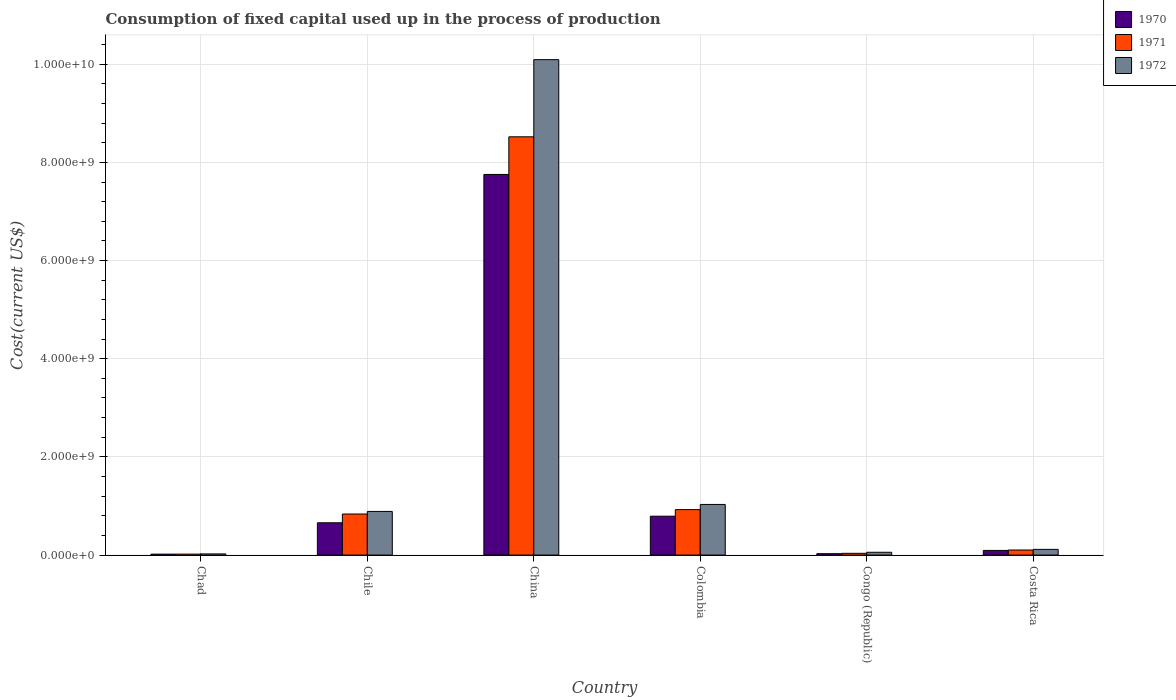How many different coloured bars are there?
Make the answer very short. 3. How many groups of bars are there?
Offer a very short reply. 6. How many bars are there on the 4th tick from the left?
Your answer should be very brief. 3. What is the label of the 1st group of bars from the left?
Offer a very short reply. Chad. In how many cases, is the number of bars for a given country not equal to the number of legend labels?
Keep it short and to the point. 0. What is the amount consumed in the process of production in 1970 in Chile?
Make the answer very short. 6.58e+08. Across all countries, what is the maximum amount consumed in the process of production in 1970?
Provide a succinct answer. 7.75e+09. Across all countries, what is the minimum amount consumed in the process of production in 1972?
Ensure brevity in your answer.  2.37e+07. In which country was the amount consumed in the process of production in 1970 minimum?
Make the answer very short. Chad. What is the total amount consumed in the process of production in 1971 in the graph?
Keep it short and to the point. 1.04e+1. What is the difference between the amount consumed in the process of production in 1971 in Chile and that in Costa Rica?
Offer a very short reply. 7.34e+08. What is the difference between the amount consumed in the process of production in 1971 in Costa Rica and the amount consumed in the process of production in 1972 in China?
Ensure brevity in your answer.  -9.99e+09. What is the average amount consumed in the process of production in 1970 per country?
Your response must be concise. 1.56e+09. What is the difference between the amount consumed in the process of production of/in 1971 and amount consumed in the process of production of/in 1972 in Chad?
Offer a very short reply. -4.50e+06. What is the ratio of the amount consumed in the process of production in 1972 in Chile to that in Colombia?
Provide a short and direct response. 0.86. Is the amount consumed in the process of production in 1971 in Chad less than that in China?
Make the answer very short. Yes. What is the difference between the highest and the second highest amount consumed in the process of production in 1970?
Keep it short and to the point. 6.96e+09. What is the difference between the highest and the lowest amount consumed in the process of production in 1970?
Keep it short and to the point. 7.74e+09. Is the sum of the amount consumed in the process of production in 1972 in China and Costa Rica greater than the maximum amount consumed in the process of production in 1971 across all countries?
Keep it short and to the point. Yes. What does the 3rd bar from the left in China represents?
Your response must be concise. 1972. Is it the case that in every country, the sum of the amount consumed in the process of production in 1970 and amount consumed in the process of production in 1972 is greater than the amount consumed in the process of production in 1971?
Provide a short and direct response. Yes. How many bars are there?
Offer a terse response. 18. Are the values on the major ticks of Y-axis written in scientific E-notation?
Ensure brevity in your answer.  Yes. Does the graph contain grids?
Offer a very short reply. Yes. What is the title of the graph?
Make the answer very short. Consumption of fixed capital used up in the process of production. What is the label or title of the Y-axis?
Keep it short and to the point. Cost(current US$). What is the Cost(current US$) of 1970 in Chad?
Give a very brief answer. 1.87e+07. What is the Cost(current US$) of 1971 in Chad?
Provide a succinct answer. 1.92e+07. What is the Cost(current US$) in 1972 in Chad?
Ensure brevity in your answer.  2.37e+07. What is the Cost(current US$) of 1970 in Chile?
Give a very brief answer. 6.58e+08. What is the Cost(current US$) of 1971 in Chile?
Provide a short and direct response. 8.37e+08. What is the Cost(current US$) of 1972 in Chile?
Ensure brevity in your answer.  8.89e+08. What is the Cost(current US$) of 1970 in China?
Offer a very short reply. 7.75e+09. What is the Cost(current US$) in 1971 in China?
Provide a succinct answer. 8.52e+09. What is the Cost(current US$) in 1972 in China?
Offer a terse response. 1.01e+1. What is the Cost(current US$) of 1970 in Colombia?
Make the answer very short. 7.92e+08. What is the Cost(current US$) in 1971 in Colombia?
Keep it short and to the point. 9.26e+08. What is the Cost(current US$) of 1972 in Colombia?
Offer a terse response. 1.03e+09. What is the Cost(current US$) in 1970 in Congo (Republic)?
Make the answer very short. 2.83e+07. What is the Cost(current US$) in 1971 in Congo (Republic)?
Your answer should be compact. 3.57e+07. What is the Cost(current US$) of 1972 in Congo (Republic)?
Make the answer very short. 5.71e+07. What is the Cost(current US$) of 1970 in Costa Rica?
Keep it short and to the point. 9.49e+07. What is the Cost(current US$) in 1971 in Costa Rica?
Your response must be concise. 1.03e+08. What is the Cost(current US$) of 1972 in Costa Rica?
Your response must be concise. 1.16e+08. Across all countries, what is the maximum Cost(current US$) of 1970?
Provide a short and direct response. 7.75e+09. Across all countries, what is the maximum Cost(current US$) of 1971?
Provide a short and direct response. 8.52e+09. Across all countries, what is the maximum Cost(current US$) in 1972?
Offer a very short reply. 1.01e+1. Across all countries, what is the minimum Cost(current US$) of 1970?
Your response must be concise. 1.87e+07. Across all countries, what is the minimum Cost(current US$) in 1971?
Your response must be concise. 1.92e+07. Across all countries, what is the minimum Cost(current US$) of 1972?
Make the answer very short. 2.37e+07. What is the total Cost(current US$) in 1970 in the graph?
Offer a terse response. 9.35e+09. What is the total Cost(current US$) in 1971 in the graph?
Your answer should be compact. 1.04e+1. What is the total Cost(current US$) in 1972 in the graph?
Keep it short and to the point. 1.22e+1. What is the difference between the Cost(current US$) in 1970 in Chad and that in Chile?
Your response must be concise. -6.39e+08. What is the difference between the Cost(current US$) in 1971 in Chad and that in Chile?
Your answer should be very brief. -8.17e+08. What is the difference between the Cost(current US$) in 1972 in Chad and that in Chile?
Your answer should be compact. -8.65e+08. What is the difference between the Cost(current US$) of 1970 in Chad and that in China?
Ensure brevity in your answer.  -7.74e+09. What is the difference between the Cost(current US$) of 1971 in Chad and that in China?
Provide a succinct answer. -8.50e+09. What is the difference between the Cost(current US$) of 1972 in Chad and that in China?
Keep it short and to the point. -1.01e+1. What is the difference between the Cost(current US$) of 1970 in Chad and that in Colombia?
Provide a short and direct response. -7.73e+08. What is the difference between the Cost(current US$) in 1971 in Chad and that in Colombia?
Ensure brevity in your answer.  -9.07e+08. What is the difference between the Cost(current US$) in 1972 in Chad and that in Colombia?
Your answer should be very brief. -1.01e+09. What is the difference between the Cost(current US$) of 1970 in Chad and that in Congo (Republic)?
Your answer should be compact. -9.59e+06. What is the difference between the Cost(current US$) of 1971 in Chad and that in Congo (Republic)?
Keep it short and to the point. -1.65e+07. What is the difference between the Cost(current US$) of 1972 in Chad and that in Congo (Republic)?
Offer a terse response. -3.35e+07. What is the difference between the Cost(current US$) in 1970 in Chad and that in Costa Rica?
Give a very brief answer. -7.62e+07. What is the difference between the Cost(current US$) in 1971 in Chad and that in Costa Rica?
Ensure brevity in your answer.  -8.39e+07. What is the difference between the Cost(current US$) in 1972 in Chad and that in Costa Rica?
Provide a short and direct response. -9.27e+07. What is the difference between the Cost(current US$) in 1970 in Chile and that in China?
Your response must be concise. -7.10e+09. What is the difference between the Cost(current US$) in 1971 in Chile and that in China?
Offer a terse response. -7.68e+09. What is the difference between the Cost(current US$) of 1972 in Chile and that in China?
Offer a terse response. -9.20e+09. What is the difference between the Cost(current US$) in 1970 in Chile and that in Colombia?
Offer a very short reply. -1.34e+08. What is the difference between the Cost(current US$) of 1971 in Chile and that in Colombia?
Offer a terse response. -8.94e+07. What is the difference between the Cost(current US$) of 1972 in Chile and that in Colombia?
Make the answer very short. -1.42e+08. What is the difference between the Cost(current US$) in 1970 in Chile and that in Congo (Republic)?
Offer a very short reply. 6.30e+08. What is the difference between the Cost(current US$) of 1971 in Chile and that in Congo (Republic)?
Your answer should be very brief. 8.01e+08. What is the difference between the Cost(current US$) in 1972 in Chile and that in Congo (Republic)?
Your answer should be very brief. 8.32e+08. What is the difference between the Cost(current US$) of 1970 in Chile and that in Costa Rica?
Ensure brevity in your answer.  5.63e+08. What is the difference between the Cost(current US$) of 1971 in Chile and that in Costa Rica?
Provide a short and direct response. 7.34e+08. What is the difference between the Cost(current US$) of 1972 in Chile and that in Costa Rica?
Your answer should be very brief. 7.73e+08. What is the difference between the Cost(current US$) in 1970 in China and that in Colombia?
Provide a succinct answer. 6.96e+09. What is the difference between the Cost(current US$) in 1971 in China and that in Colombia?
Give a very brief answer. 7.60e+09. What is the difference between the Cost(current US$) in 1972 in China and that in Colombia?
Your answer should be compact. 9.06e+09. What is the difference between the Cost(current US$) of 1970 in China and that in Congo (Republic)?
Provide a succinct answer. 7.73e+09. What is the difference between the Cost(current US$) in 1971 in China and that in Congo (Republic)?
Your answer should be compact. 8.49e+09. What is the difference between the Cost(current US$) in 1972 in China and that in Congo (Republic)?
Keep it short and to the point. 1.00e+1. What is the difference between the Cost(current US$) of 1970 in China and that in Costa Rica?
Make the answer very short. 7.66e+09. What is the difference between the Cost(current US$) of 1971 in China and that in Costa Rica?
Ensure brevity in your answer.  8.42e+09. What is the difference between the Cost(current US$) of 1972 in China and that in Costa Rica?
Keep it short and to the point. 9.98e+09. What is the difference between the Cost(current US$) in 1970 in Colombia and that in Congo (Republic)?
Offer a very short reply. 7.64e+08. What is the difference between the Cost(current US$) of 1971 in Colombia and that in Congo (Republic)?
Provide a short and direct response. 8.90e+08. What is the difference between the Cost(current US$) in 1972 in Colombia and that in Congo (Republic)?
Ensure brevity in your answer.  9.74e+08. What is the difference between the Cost(current US$) of 1970 in Colombia and that in Costa Rica?
Give a very brief answer. 6.97e+08. What is the difference between the Cost(current US$) of 1971 in Colombia and that in Costa Rica?
Your answer should be compact. 8.23e+08. What is the difference between the Cost(current US$) in 1972 in Colombia and that in Costa Rica?
Give a very brief answer. 9.15e+08. What is the difference between the Cost(current US$) of 1970 in Congo (Republic) and that in Costa Rica?
Offer a terse response. -6.66e+07. What is the difference between the Cost(current US$) in 1971 in Congo (Republic) and that in Costa Rica?
Make the answer very short. -6.74e+07. What is the difference between the Cost(current US$) in 1972 in Congo (Republic) and that in Costa Rica?
Your answer should be very brief. -5.92e+07. What is the difference between the Cost(current US$) of 1970 in Chad and the Cost(current US$) of 1971 in Chile?
Ensure brevity in your answer.  -8.18e+08. What is the difference between the Cost(current US$) of 1970 in Chad and the Cost(current US$) of 1972 in Chile?
Provide a short and direct response. -8.70e+08. What is the difference between the Cost(current US$) of 1971 in Chad and the Cost(current US$) of 1972 in Chile?
Your answer should be compact. -8.70e+08. What is the difference between the Cost(current US$) of 1970 in Chad and the Cost(current US$) of 1971 in China?
Offer a terse response. -8.50e+09. What is the difference between the Cost(current US$) in 1970 in Chad and the Cost(current US$) in 1972 in China?
Provide a succinct answer. -1.01e+1. What is the difference between the Cost(current US$) in 1971 in Chad and the Cost(current US$) in 1972 in China?
Your answer should be compact. -1.01e+1. What is the difference between the Cost(current US$) in 1970 in Chad and the Cost(current US$) in 1971 in Colombia?
Ensure brevity in your answer.  -9.07e+08. What is the difference between the Cost(current US$) in 1970 in Chad and the Cost(current US$) in 1972 in Colombia?
Your response must be concise. -1.01e+09. What is the difference between the Cost(current US$) in 1971 in Chad and the Cost(current US$) in 1972 in Colombia?
Your response must be concise. -1.01e+09. What is the difference between the Cost(current US$) of 1970 in Chad and the Cost(current US$) of 1971 in Congo (Republic)?
Provide a short and direct response. -1.70e+07. What is the difference between the Cost(current US$) in 1970 in Chad and the Cost(current US$) in 1972 in Congo (Republic)?
Give a very brief answer. -3.85e+07. What is the difference between the Cost(current US$) of 1971 in Chad and the Cost(current US$) of 1972 in Congo (Republic)?
Ensure brevity in your answer.  -3.80e+07. What is the difference between the Cost(current US$) in 1970 in Chad and the Cost(current US$) in 1971 in Costa Rica?
Offer a very short reply. -8.43e+07. What is the difference between the Cost(current US$) of 1970 in Chad and the Cost(current US$) of 1972 in Costa Rica?
Provide a short and direct response. -9.76e+07. What is the difference between the Cost(current US$) of 1971 in Chad and the Cost(current US$) of 1972 in Costa Rica?
Make the answer very short. -9.72e+07. What is the difference between the Cost(current US$) in 1970 in Chile and the Cost(current US$) in 1971 in China?
Give a very brief answer. -7.86e+09. What is the difference between the Cost(current US$) of 1970 in Chile and the Cost(current US$) of 1972 in China?
Give a very brief answer. -9.44e+09. What is the difference between the Cost(current US$) of 1971 in Chile and the Cost(current US$) of 1972 in China?
Provide a short and direct response. -9.26e+09. What is the difference between the Cost(current US$) of 1970 in Chile and the Cost(current US$) of 1971 in Colombia?
Ensure brevity in your answer.  -2.68e+08. What is the difference between the Cost(current US$) in 1970 in Chile and the Cost(current US$) in 1972 in Colombia?
Provide a succinct answer. -3.73e+08. What is the difference between the Cost(current US$) in 1971 in Chile and the Cost(current US$) in 1972 in Colombia?
Give a very brief answer. -1.95e+08. What is the difference between the Cost(current US$) of 1970 in Chile and the Cost(current US$) of 1971 in Congo (Republic)?
Make the answer very short. 6.22e+08. What is the difference between the Cost(current US$) of 1970 in Chile and the Cost(current US$) of 1972 in Congo (Republic)?
Provide a succinct answer. 6.01e+08. What is the difference between the Cost(current US$) in 1971 in Chile and the Cost(current US$) in 1972 in Congo (Republic)?
Ensure brevity in your answer.  7.79e+08. What is the difference between the Cost(current US$) of 1970 in Chile and the Cost(current US$) of 1971 in Costa Rica?
Give a very brief answer. 5.55e+08. What is the difference between the Cost(current US$) in 1970 in Chile and the Cost(current US$) in 1972 in Costa Rica?
Your answer should be compact. 5.41e+08. What is the difference between the Cost(current US$) of 1971 in Chile and the Cost(current US$) of 1972 in Costa Rica?
Offer a very short reply. 7.20e+08. What is the difference between the Cost(current US$) in 1970 in China and the Cost(current US$) in 1971 in Colombia?
Your answer should be compact. 6.83e+09. What is the difference between the Cost(current US$) in 1970 in China and the Cost(current US$) in 1972 in Colombia?
Keep it short and to the point. 6.72e+09. What is the difference between the Cost(current US$) of 1971 in China and the Cost(current US$) of 1972 in Colombia?
Make the answer very short. 7.49e+09. What is the difference between the Cost(current US$) in 1970 in China and the Cost(current US$) in 1971 in Congo (Republic)?
Your answer should be compact. 7.72e+09. What is the difference between the Cost(current US$) of 1970 in China and the Cost(current US$) of 1972 in Congo (Republic)?
Your response must be concise. 7.70e+09. What is the difference between the Cost(current US$) in 1971 in China and the Cost(current US$) in 1972 in Congo (Republic)?
Give a very brief answer. 8.46e+09. What is the difference between the Cost(current US$) in 1970 in China and the Cost(current US$) in 1971 in Costa Rica?
Make the answer very short. 7.65e+09. What is the difference between the Cost(current US$) of 1970 in China and the Cost(current US$) of 1972 in Costa Rica?
Keep it short and to the point. 7.64e+09. What is the difference between the Cost(current US$) in 1971 in China and the Cost(current US$) in 1972 in Costa Rica?
Provide a succinct answer. 8.40e+09. What is the difference between the Cost(current US$) in 1970 in Colombia and the Cost(current US$) in 1971 in Congo (Republic)?
Offer a terse response. 7.56e+08. What is the difference between the Cost(current US$) in 1970 in Colombia and the Cost(current US$) in 1972 in Congo (Republic)?
Keep it short and to the point. 7.35e+08. What is the difference between the Cost(current US$) in 1971 in Colombia and the Cost(current US$) in 1972 in Congo (Republic)?
Offer a terse response. 8.69e+08. What is the difference between the Cost(current US$) in 1970 in Colombia and the Cost(current US$) in 1971 in Costa Rica?
Your response must be concise. 6.89e+08. What is the difference between the Cost(current US$) of 1970 in Colombia and the Cost(current US$) of 1972 in Costa Rica?
Give a very brief answer. 6.76e+08. What is the difference between the Cost(current US$) in 1971 in Colombia and the Cost(current US$) in 1972 in Costa Rica?
Provide a succinct answer. 8.10e+08. What is the difference between the Cost(current US$) in 1970 in Congo (Republic) and the Cost(current US$) in 1971 in Costa Rica?
Provide a short and direct response. -7.48e+07. What is the difference between the Cost(current US$) of 1970 in Congo (Republic) and the Cost(current US$) of 1972 in Costa Rica?
Your answer should be compact. -8.80e+07. What is the difference between the Cost(current US$) in 1971 in Congo (Republic) and the Cost(current US$) in 1972 in Costa Rica?
Offer a very short reply. -8.07e+07. What is the average Cost(current US$) in 1970 per country?
Ensure brevity in your answer.  1.56e+09. What is the average Cost(current US$) of 1971 per country?
Your answer should be compact. 1.74e+09. What is the average Cost(current US$) in 1972 per country?
Make the answer very short. 2.04e+09. What is the difference between the Cost(current US$) of 1970 and Cost(current US$) of 1971 in Chad?
Your response must be concise. -4.79e+05. What is the difference between the Cost(current US$) in 1970 and Cost(current US$) in 1972 in Chad?
Provide a succinct answer. -4.98e+06. What is the difference between the Cost(current US$) of 1971 and Cost(current US$) of 1972 in Chad?
Keep it short and to the point. -4.50e+06. What is the difference between the Cost(current US$) in 1970 and Cost(current US$) in 1971 in Chile?
Give a very brief answer. -1.79e+08. What is the difference between the Cost(current US$) of 1970 and Cost(current US$) of 1972 in Chile?
Keep it short and to the point. -2.31e+08. What is the difference between the Cost(current US$) in 1971 and Cost(current US$) in 1972 in Chile?
Offer a terse response. -5.24e+07. What is the difference between the Cost(current US$) of 1970 and Cost(current US$) of 1971 in China?
Ensure brevity in your answer.  -7.67e+08. What is the difference between the Cost(current US$) in 1970 and Cost(current US$) in 1972 in China?
Give a very brief answer. -2.34e+09. What is the difference between the Cost(current US$) in 1971 and Cost(current US$) in 1972 in China?
Make the answer very short. -1.57e+09. What is the difference between the Cost(current US$) in 1970 and Cost(current US$) in 1971 in Colombia?
Provide a short and direct response. -1.34e+08. What is the difference between the Cost(current US$) in 1970 and Cost(current US$) in 1972 in Colombia?
Keep it short and to the point. -2.39e+08. What is the difference between the Cost(current US$) in 1971 and Cost(current US$) in 1972 in Colombia?
Keep it short and to the point. -1.05e+08. What is the difference between the Cost(current US$) of 1970 and Cost(current US$) of 1971 in Congo (Republic)?
Offer a terse response. -7.38e+06. What is the difference between the Cost(current US$) of 1970 and Cost(current US$) of 1972 in Congo (Republic)?
Your answer should be very brief. -2.89e+07. What is the difference between the Cost(current US$) of 1971 and Cost(current US$) of 1972 in Congo (Republic)?
Your answer should be compact. -2.15e+07. What is the difference between the Cost(current US$) of 1970 and Cost(current US$) of 1971 in Costa Rica?
Keep it short and to the point. -8.14e+06. What is the difference between the Cost(current US$) in 1970 and Cost(current US$) in 1972 in Costa Rica?
Your answer should be compact. -2.14e+07. What is the difference between the Cost(current US$) in 1971 and Cost(current US$) in 1972 in Costa Rica?
Offer a very short reply. -1.33e+07. What is the ratio of the Cost(current US$) in 1970 in Chad to that in Chile?
Give a very brief answer. 0.03. What is the ratio of the Cost(current US$) of 1971 in Chad to that in Chile?
Keep it short and to the point. 0.02. What is the ratio of the Cost(current US$) of 1972 in Chad to that in Chile?
Offer a terse response. 0.03. What is the ratio of the Cost(current US$) in 1970 in Chad to that in China?
Your answer should be very brief. 0. What is the ratio of the Cost(current US$) in 1971 in Chad to that in China?
Offer a very short reply. 0. What is the ratio of the Cost(current US$) of 1972 in Chad to that in China?
Your response must be concise. 0. What is the ratio of the Cost(current US$) of 1970 in Chad to that in Colombia?
Your response must be concise. 0.02. What is the ratio of the Cost(current US$) of 1971 in Chad to that in Colombia?
Give a very brief answer. 0.02. What is the ratio of the Cost(current US$) of 1972 in Chad to that in Colombia?
Your response must be concise. 0.02. What is the ratio of the Cost(current US$) of 1970 in Chad to that in Congo (Republic)?
Your answer should be very brief. 0.66. What is the ratio of the Cost(current US$) of 1971 in Chad to that in Congo (Republic)?
Provide a short and direct response. 0.54. What is the ratio of the Cost(current US$) of 1972 in Chad to that in Congo (Republic)?
Provide a succinct answer. 0.41. What is the ratio of the Cost(current US$) in 1970 in Chad to that in Costa Rica?
Your response must be concise. 0.2. What is the ratio of the Cost(current US$) of 1971 in Chad to that in Costa Rica?
Your response must be concise. 0.19. What is the ratio of the Cost(current US$) in 1972 in Chad to that in Costa Rica?
Make the answer very short. 0.2. What is the ratio of the Cost(current US$) of 1970 in Chile to that in China?
Your response must be concise. 0.08. What is the ratio of the Cost(current US$) in 1971 in Chile to that in China?
Provide a succinct answer. 0.1. What is the ratio of the Cost(current US$) of 1972 in Chile to that in China?
Provide a short and direct response. 0.09. What is the ratio of the Cost(current US$) in 1970 in Chile to that in Colombia?
Ensure brevity in your answer.  0.83. What is the ratio of the Cost(current US$) of 1971 in Chile to that in Colombia?
Provide a short and direct response. 0.9. What is the ratio of the Cost(current US$) of 1972 in Chile to that in Colombia?
Give a very brief answer. 0.86. What is the ratio of the Cost(current US$) in 1970 in Chile to that in Congo (Republic)?
Your answer should be compact. 23.26. What is the ratio of the Cost(current US$) of 1971 in Chile to that in Congo (Republic)?
Your answer should be very brief. 23.46. What is the ratio of the Cost(current US$) in 1972 in Chile to that in Congo (Republic)?
Offer a terse response. 15.56. What is the ratio of the Cost(current US$) of 1970 in Chile to that in Costa Rica?
Provide a succinct answer. 6.93. What is the ratio of the Cost(current US$) in 1971 in Chile to that in Costa Rica?
Your answer should be very brief. 8.12. What is the ratio of the Cost(current US$) in 1972 in Chile to that in Costa Rica?
Offer a very short reply. 7.64. What is the ratio of the Cost(current US$) in 1970 in China to that in Colombia?
Make the answer very short. 9.79. What is the ratio of the Cost(current US$) of 1971 in China to that in Colombia?
Make the answer very short. 9.2. What is the ratio of the Cost(current US$) of 1972 in China to that in Colombia?
Keep it short and to the point. 9.79. What is the ratio of the Cost(current US$) in 1970 in China to that in Congo (Republic)?
Make the answer very short. 274.16. What is the ratio of the Cost(current US$) of 1971 in China to that in Congo (Republic)?
Provide a succinct answer. 238.93. What is the ratio of the Cost(current US$) of 1972 in China to that in Congo (Republic)?
Make the answer very short. 176.62. What is the ratio of the Cost(current US$) in 1970 in China to that in Costa Rica?
Your response must be concise. 81.71. What is the ratio of the Cost(current US$) in 1971 in China to that in Costa Rica?
Give a very brief answer. 82.7. What is the ratio of the Cost(current US$) of 1972 in China to that in Costa Rica?
Your response must be concise. 86.76. What is the ratio of the Cost(current US$) of 1970 in Colombia to that in Congo (Republic)?
Provide a short and direct response. 28. What is the ratio of the Cost(current US$) in 1971 in Colombia to that in Congo (Republic)?
Your response must be concise. 25.97. What is the ratio of the Cost(current US$) of 1972 in Colombia to that in Congo (Republic)?
Ensure brevity in your answer.  18.05. What is the ratio of the Cost(current US$) in 1970 in Colombia to that in Costa Rica?
Give a very brief answer. 8.34. What is the ratio of the Cost(current US$) in 1971 in Colombia to that in Costa Rica?
Provide a succinct answer. 8.99. What is the ratio of the Cost(current US$) in 1972 in Colombia to that in Costa Rica?
Give a very brief answer. 8.86. What is the ratio of the Cost(current US$) in 1970 in Congo (Republic) to that in Costa Rica?
Keep it short and to the point. 0.3. What is the ratio of the Cost(current US$) in 1971 in Congo (Republic) to that in Costa Rica?
Provide a succinct answer. 0.35. What is the ratio of the Cost(current US$) of 1972 in Congo (Republic) to that in Costa Rica?
Provide a succinct answer. 0.49. What is the difference between the highest and the second highest Cost(current US$) in 1970?
Provide a short and direct response. 6.96e+09. What is the difference between the highest and the second highest Cost(current US$) in 1971?
Give a very brief answer. 7.60e+09. What is the difference between the highest and the second highest Cost(current US$) of 1972?
Your response must be concise. 9.06e+09. What is the difference between the highest and the lowest Cost(current US$) in 1970?
Ensure brevity in your answer.  7.74e+09. What is the difference between the highest and the lowest Cost(current US$) of 1971?
Make the answer very short. 8.50e+09. What is the difference between the highest and the lowest Cost(current US$) of 1972?
Give a very brief answer. 1.01e+1. 